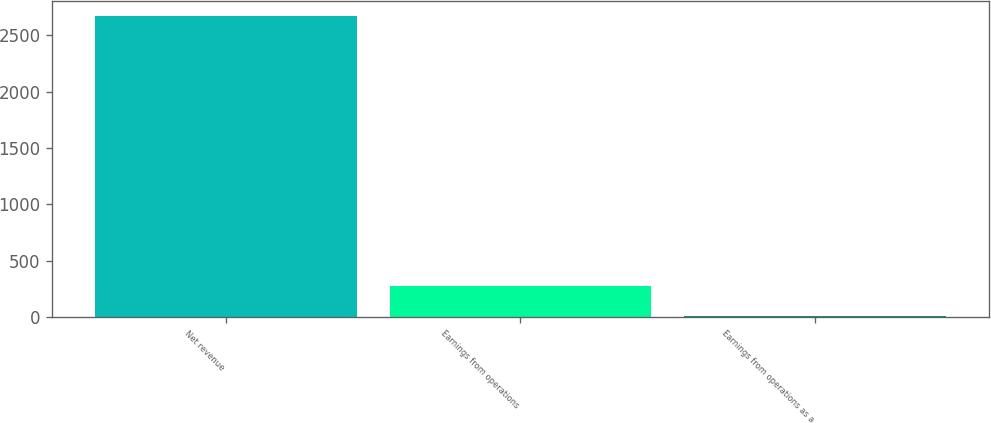Convert chart to OTSL. <chart><loc_0><loc_0><loc_500><loc_500><bar_chart><fcel>Net revenue<fcel>Earnings from operations<fcel>Earnings from operations as a<nl><fcel>2673<fcel>274.23<fcel>7.7<nl></chart> 